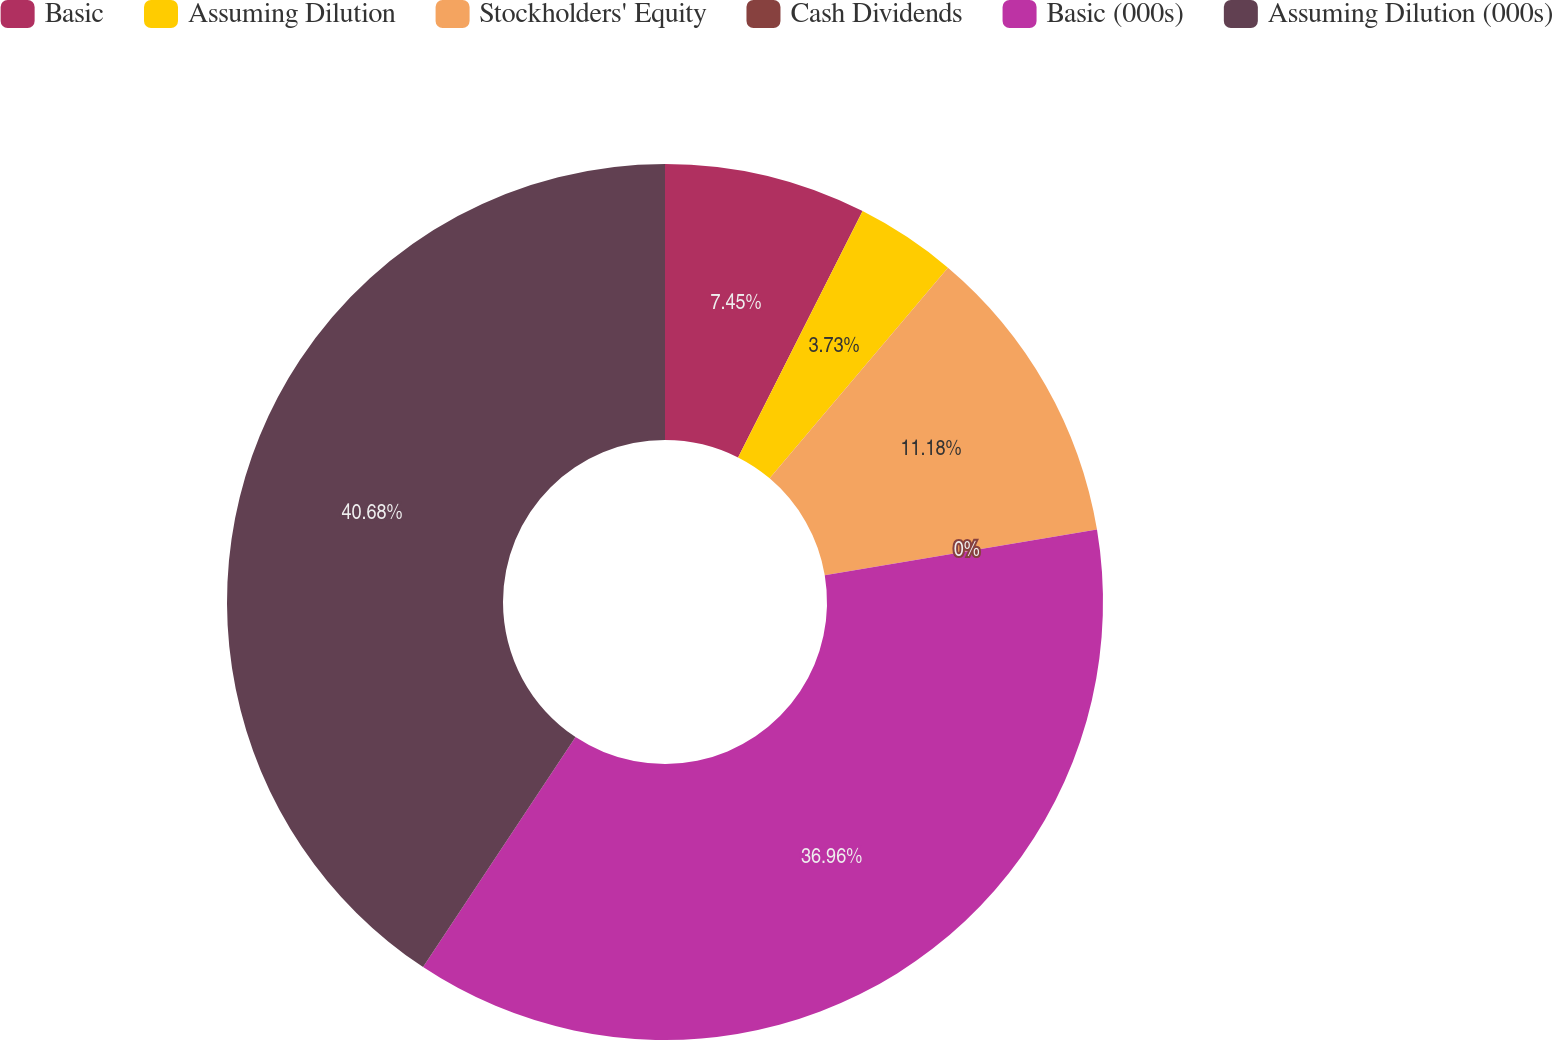<chart> <loc_0><loc_0><loc_500><loc_500><pie_chart><fcel>Basic<fcel>Assuming Dilution<fcel>Stockholders' Equity<fcel>Cash Dividends<fcel>Basic (000s)<fcel>Assuming Dilution (000s)<nl><fcel>7.45%<fcel>3.73%<fcel>11.18%<fcel>0.0%<fcel>36.96%<fcel>40.69%<nl></chart> 